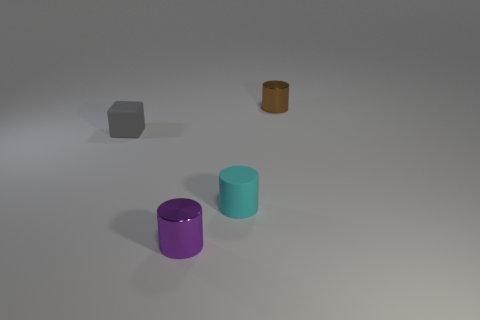What time of day does the lighting in the scene suggest? The soft and diffuse nature of the shadows suggests it may be an overcast day or the objects are placed in a room with even artificial lighting, rather than a specific time of day with natural light. 